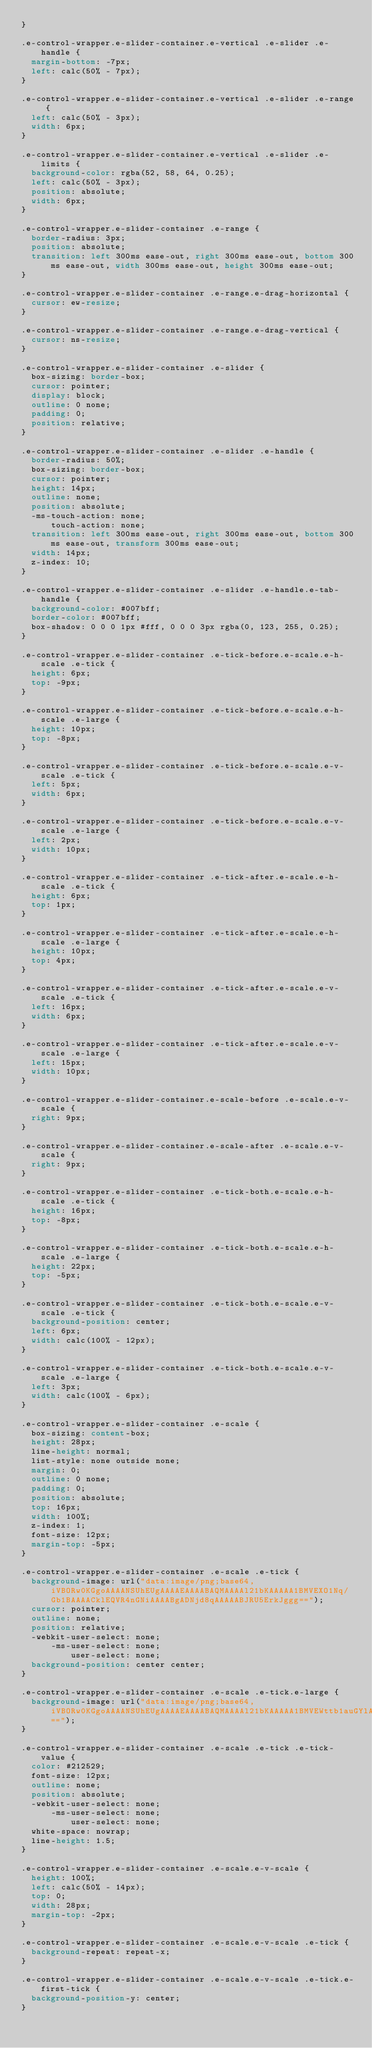<code> <loc_0><loc_0><loc_500><loc_500><_CSS_>}

.e-control-wrapper.e-slider-container.e-vertical .e-slider .e-handle {
  margin-bottom: -7px;
  left: calc(50% - 7px);
}

.e-control-wrapper.e-slider-container.e-vertical .e-slider .e-range {
  left: calc(50% - 3px);
  width: 6px;
}

.e-control-wrapper.e-slider-container.e-vertical .e-slider .e-limits {
  background-color: rgba(52, 58, 64, 0.25);
  left: calc(50% - 3px);
  position: absolute;
  width: 6px;
}

.e-control-wrapper.e-slider-container .e-range {
  border-radius: 3px;
  position: absolute;
  transition: left 300ms ease-out, right 300ms ease-out, bottom 300ms ease-out, width 300ms ease-out, height 300ms ease-out;
}

.e-control-wrapper.e-slider-container .e-range.e-drag-horizontal {
  cursor: ew-resize;
}

.e-control-wrapper.e-slider-container .e-range.e-drag-vertical {
  cursor: ns-resize;
}

.e-control-wrapper.e-slider-container .e-slider {
  box-sizing: border-box;
  cursor: pointer;
  display: block;
  outline: 0 none;
  padding: 0;
  position: relative;
}

.e-control-wrapper.e-slider-container .e-slider .e-handle {
  border-radius: 50%;
  box-sizing: border-box;
  cursor: pointer;
  height: 14px;
  outline: none;
  position: absolute;
  -ms-touch-action: none;
      touch-action: none;
  transition: left 300ms ease-out, right 300ms ease-out, bottom 300ms ease-out, transform 300ms ease-out;
  width: 14px;
  z-index: 10;
}

.e-control-wrapper.e-slider-container .e-slider .e-handle.e-tab-handle {
  background-color: #007bff;
  border-color: #007bff;
  box-shadow: 0 0 0 1px #fff, 0 0 0 3px rgba(0, 123, 255, 0.25);
}

.e-control-wrapper.e-slider-container .e-tick-before.e-scale.e-h-scale .e-tick {
  height: 6px;
  top: -9px;
}

.e-control-wrapper.e-slider-container .e-tick-before.e-scale.e-h-scale .e-large {
  height: 10px;
  top: -8px;
}

.e-control-wrapper.e-slider-container .e-tick-before.e-scale.e-v-scale .e-tick {
  left: 5px;
  width: 6px;
}

.e-control-wrapper.e-slider-container .e-tick-before.e-scale.e-v-scale .e-large {
  left: 2px;
  width: 10px;
}

.e-control-wrapper.e-slider-container .e-tick-after.e-scale.e-h-scale .e-tick {
  height: 6px;
  top: 1px;
}

.e-control-wrapper.e-slider-container .e-tick-after.e-scale.e-h-scale .e-large {
  height: 10px;
  top: 4px;
}

.e-control-wrapper.e-slider-container .e-tick-after.e-scale.e-v-scale .e-tick {
  left: 16px;
  width: 6px;
}

.e-control-wrapper.e-slider-container .e-tick-after.e-scale.e-v-scale .e-large {
  left: 15px;
  width: 10px;
}

.e-control-wrapper.e-slider-container.e-scale-before .e-scale.e-v-scale {
  right: 9px;
}

.e-control-wrapper.e-slider-container.e-scale-after .e-scale.e-v-scale {
  right: 9px;
}

.e-control-wrapper.e-slider-container .e-tick-both.e-scale.e-h-scale .e-tick {
  height: 16px;
  top: -8px;
}

.e-control-wrapper.e-slider-container .e-tick-both.e-scale.e-h-scale .e-large {
  height: 22px;
  top: -5px;
}

.e-control-wrapper.e-slider-container .e-tick-both.e-scale.e-v-scale .e-tick {
  background-position: center;
  left: 6px;
  width: calc(100% - 12px);
}

.e-control-wrapper.e-slider-container .e-tick-both.e-scale.e-v-scale .e-large {
  left: 3px;
  width: calc(100% - 6px);
}

.e-control-wrapper.e-slider-container .e-scale {
  box-sizing: content-box;
  height: 28px;
  line-height: normal;
  list-style: none outside none;
  margin: 0;
  outline: 0 none;
  padding: 0;
  position: absolute;
  top: 16px;
  width: 100%;
  z-index: 1;
  font-size: 12px;
  margin-top: -5px;
}

.e-control-wrapper.e-slider-container .e-scale .e-tick {
  background-image: url("data:image/png;base64,iVBORw0KGgoAAAANSUhEUgAAAAEAAAABAQMAAAAl21bKAAAAA1BMVEXO1Nq/Gb1BAAAACklEQVR4nGNiAAAABgADNjd8qAAAAABJRU5ErkJggg==");
  cursor: pointer;
  outline: none;
  position: relative;
  -webkit-user-select: none;
      -ms-user-select: none;
          user-select: none;
  background-position: center center;
}

.e-control-wrapper.e-slider-container .e-scale .e-tick.e-large {
  background-image: url("data:image/png;base64,iVBORw0KGgoAAAANSUhEUgAAAAEAAAABAQMAAAAl21bKAAAAA1BMVEWttb1auGYlAAAACklEQVR4nGNiAAAABgADNjd8qAAAAABJRU5ErkJggg==");
}

.e-control-wrapper.e-slider-container .e-scale .e-tick .e-tick-value {
  color: #212529;
  font-size: 12px;
  outline: none;
  position: absolute;
  -webkit-user-select: none;
      -ms-user-select: none;
          user-select: none;
  white-space: nowrap;
  line-height: 1.5;
}

.e-control-wrapper.e-slider-container .e-scale.e-v-scale {
  height: 100%;
  left: calc(50% - 14px);
  top: 0;
  width: 28px;
  margin-top: -2px;
}

.e-control-wrapper.e-slider-container .e-scale.e-v-scale .e-tick {
  background-repeat: repeat-x;
}

.e-control-wrapper.e-slider-container .e-scale.e-v-scale .e-tick.e-first-tick {
  background-position-y: center;
}
</code> 